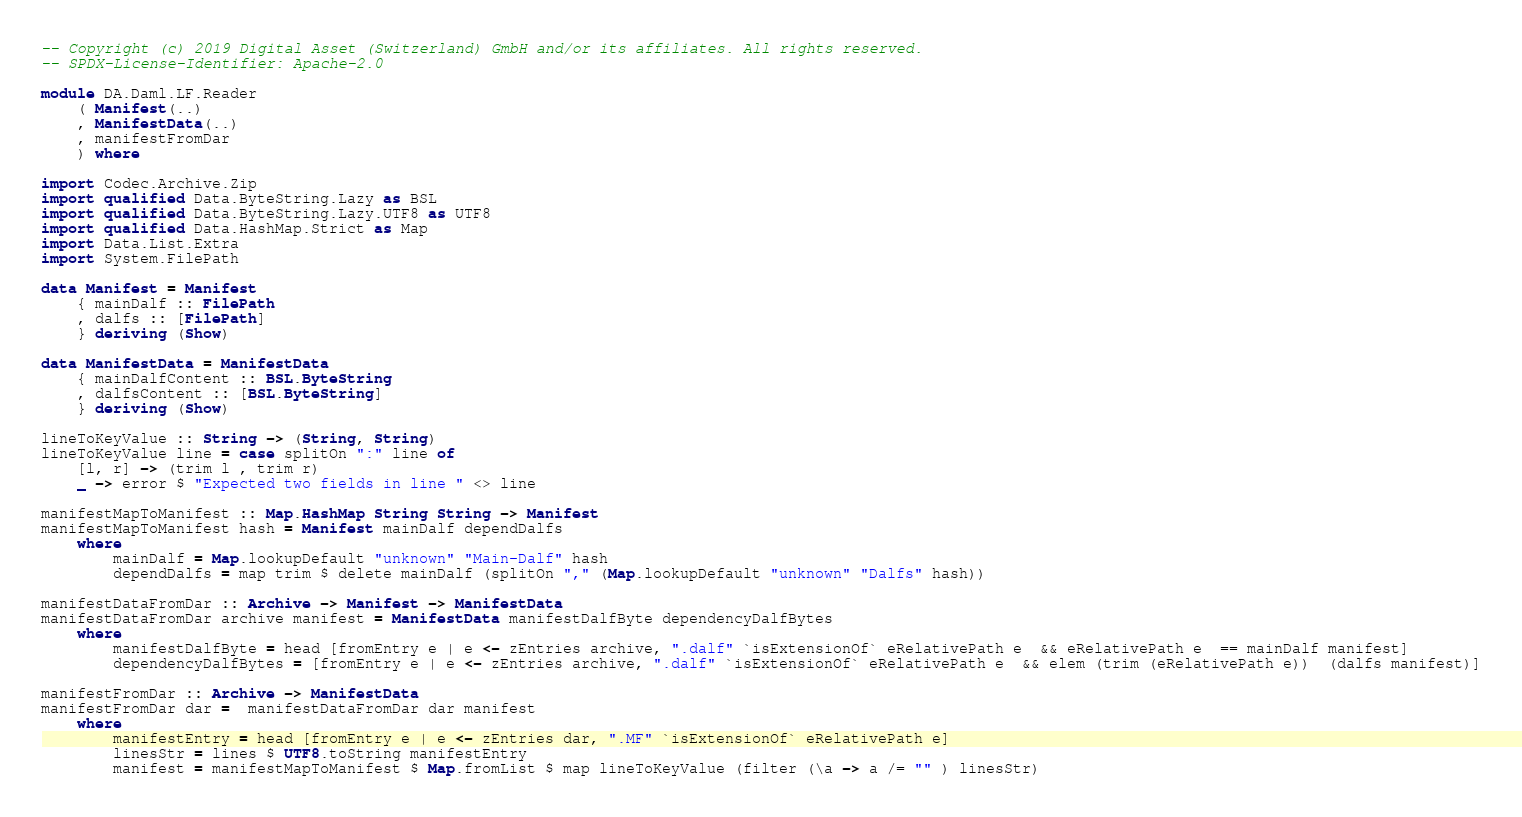Convert code to text. <code><loc_0><loc_0><loc_500><loc_500><_Haskell_>-- Copyright (c) 2019 Digital Asset (Switzerland) GmbH and/or its affiliates. All rights reserved.
-- SPDX-License-Identifier: Apache-2.0

module DA.Daml.LF.Reader
    ( Manifest(..)
    , ManifestData(..)
    , manifestFromDar
    ) where

import Codec.Archive.Zip
import qualified Data.ByteString.Lazy as BSL
import qualified Data.ByteString.Lazy.UTF8 as UTF8
import qualified Data.HashMap.Strict as Map
import Data.List.Extra
import System.FilePath

data Manifest = Manifest
    { mainDalf :: FilePath
    , dalfs :: [FilePath]
    } deriving (Show)

data ManifestData = ManifestData
    { mainDalfContent :: BSL.ByteString
    , dalfsContent :: [BSL.ByteString]
    } deriving (Show)

lineToKeyValue :: String -> (String, String)
lineToKeyValue line = case splitOn ":" line of
    [l, r] -> (trim l , trim r)
    _ -> error $ "Expected two fields in line " <> line

manifestMapToManifest :: Map.HashMap String String -> Manifest
manifestMapToManifest hash = Manifest mainDalf dependDalfs
    where
        mainDalf = Map.lookupDefault "unknown" "Main-Dalf" hash
        dependDalfs = map trim $ delete mainDalf (splitOn "," (Map.lookupDefault "unknown" "Dalfs" hash))

manifestDataFromDar :: Archive -> Manifest -> ManifestData
manifestDataFromDar archive manifest = ManifestData manifestDalfByte dependencyDalfBytes
    where
        manifestDalfByte = head [fromEntry e | e <- zEntries archive, ".dalf" `isExtensionOf` eRelativePath e  && eRelativePath e  == mainDalf manifest]
        dependencyDalfBytes = [fromEntry e | e <- zEntries archive, ".dalf" `isExtensionOf` eRelativePath e  && elem (trim (eRelativePath e))  (dalfs manifest)]

manifestFromDar :: Archive -> ManifestData
manifestFromDar dar =  manifestDataFromDar dar manifest
    where
        manifestEntry = head [fromEntry e | e <- zEntries dar, ".MF" `isExtensionOf` eRelativePath e]
        linesStr = lines $ UTF8.toString manifestEntry
        manifest = manifestMapToManifest $ Map.fromList $ map lineToKeyValue (filter (\a -> a /= "" ) linesStr)

</code> 